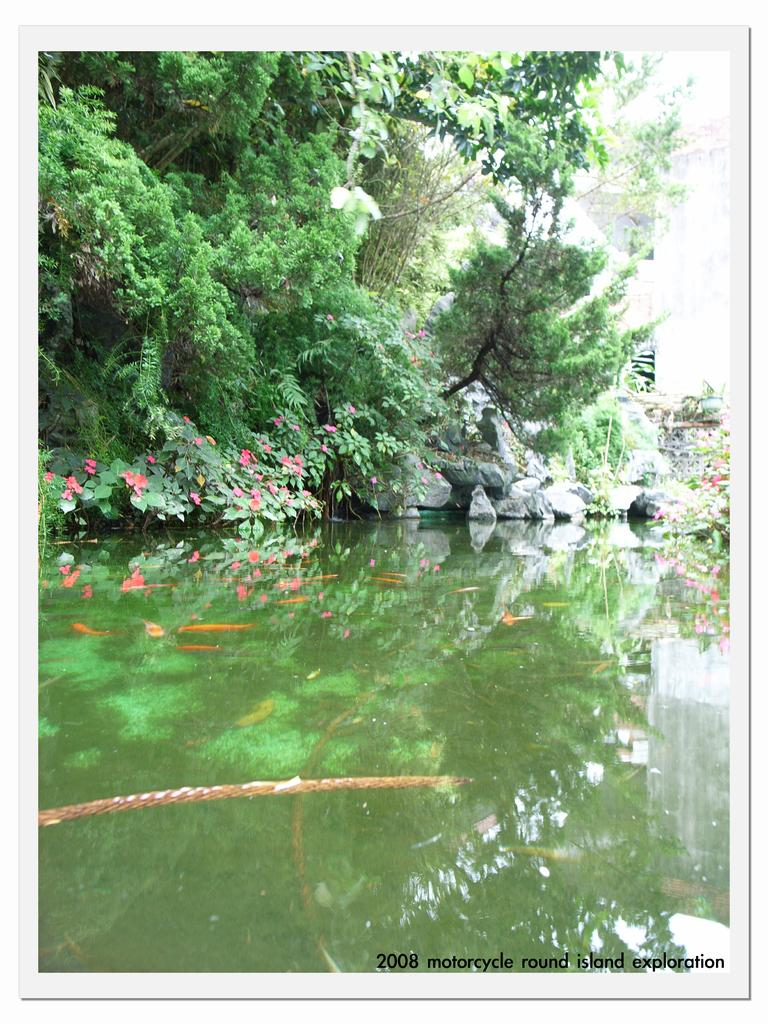What is one of the main elements in the image? There is water in the image. What type of vegetation can be seen in the image? There are trees and flowers in the image, specifically pink in color. What other natural elements are present in the image? There are rocks in the image. What can be seen in the background of the image? In the background, there is a white-colored object and the sky is visible. What type of popcorn is being played on the guitar in the image? There is no popcorn or guitar present in the image. What kind of stone is being used to create the pink flowers in the image? The image does not show any stones being used to create the pink flowers; they are natural flowers. 